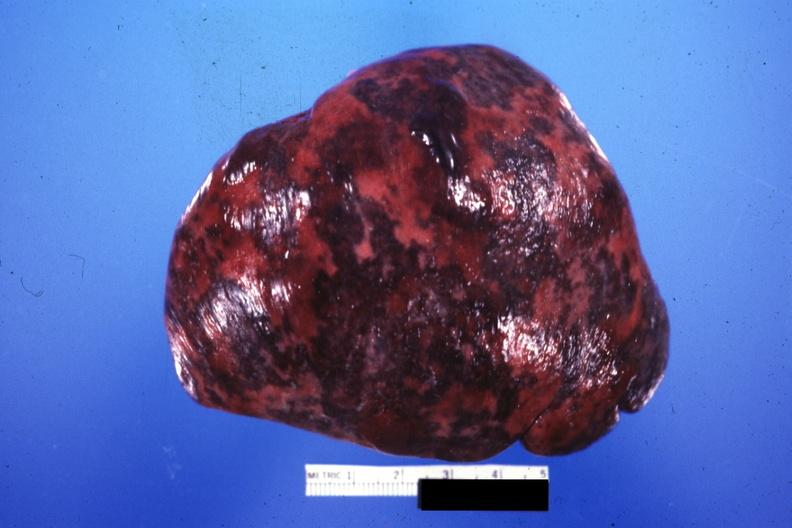what is present?
Answer the question using a single word or phrase. Infarction secondary to shock 